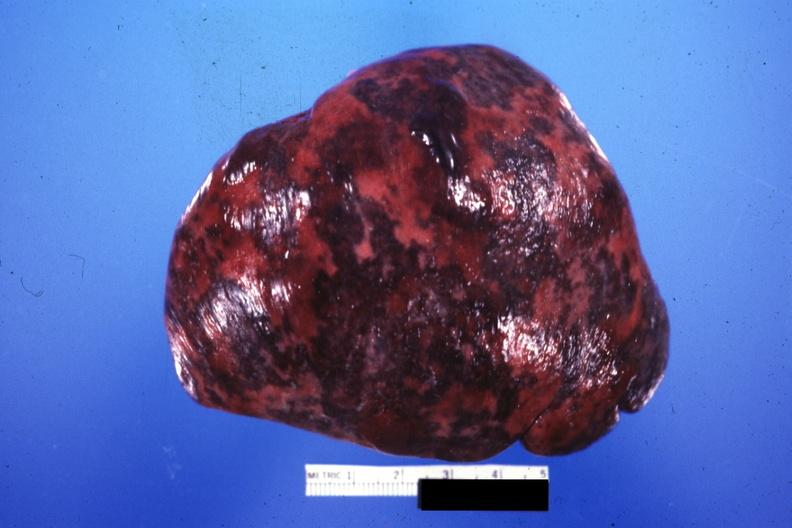what is present?
Answer the question using a single word or phrase. Infarction secondary to shock 